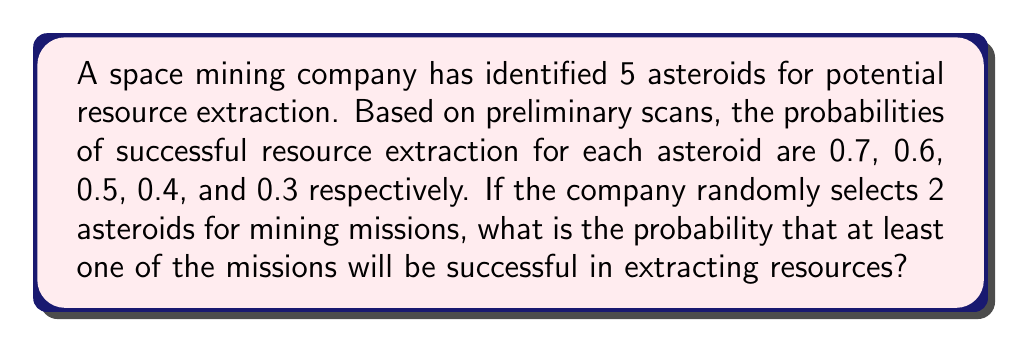Provide a solution to this math problem. Let's approach this step-by-step:

1) First, we need to calculate the probability of the complement event: the probability that both missions fail. This is easier than calculating the probability of at least one success directly.

2) The probability of selecting any two asteroids out of the five is:

   $$\binom{5}{2} = 10$$ possible combinations

3) For each combination, we multiply the failure probabilities:

   Asteroid 1 and 2: $(1-0.7)(1-0.6) = 0.3 \times 0.4 = 0.12$
   Asteroid 1 and 3: $(1-0.7)(1-0.5) = 0.3 \times 0.5 = 0.15$
   Asteroid 1 and 4: $(1-0.7)(1-0.4) = 0.3 \times 0.6 = 0.18$
   Asteroid 1 and 5: $(1-0.7)(1-0.3) = 0.3 \times 0.7 = 0.21$
   Asteroid 2 and 3: $(1-0.6)(1-0.5) = 0.4 \times 0.5 = 0.20$
   Asteroid 2 and 4: $(1-0.6)(1-0.4) = 0.4 \times 0.6 = 0.24$
   Asteroid 2 and 5: $(1-0.6)(1-0.3) = 0.4 \times 0.7 = 0.28$
   Asteroid 3 and 4: $(1-0.5)(1-0.4) = 0.5 \times 0.6 = 0.30$
   Asteroid 3 and 5: $(1-0.5)(1-0.3) = 0.5 \times 0.7 = 0.35$
   Asteroid 4 and 5: $(1-0.4)(1-0.3) = 0.6 \times 0.7 = 0.42$

4) The sum of these probabilities is 2.45

5) The average probability of both missions failing is:

   $$\frac{2.45}{10} = 0.245$$

6) Therefore, the probability of at least one mission succeeding is:

   $$1 - 0.245 = 0.755$$
Answer: 0.755 